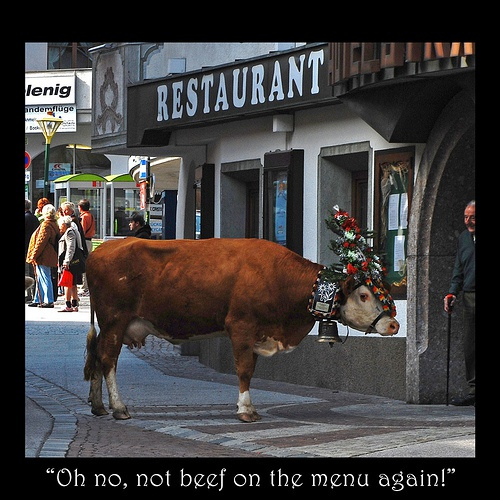Describe the objects in this image and their specific colors. I can see cow in black, maroon, brown, and gray tones, people in black, darkblue, purple, and gray tones, people in black, maroon, ivory, and blue tones, people in black, white, gray, and darkgray tones, and people in black, maroon, gray, and brown tones in this image. 